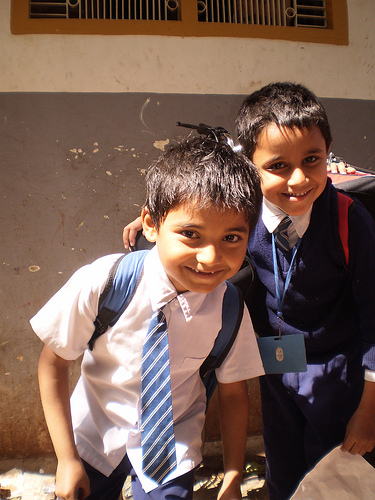<image>
Is the boy behind the boy two? No. The boy is not behind the boy two. From this viewpoint, the boy appears to be positioned elsewhere in the scene. 